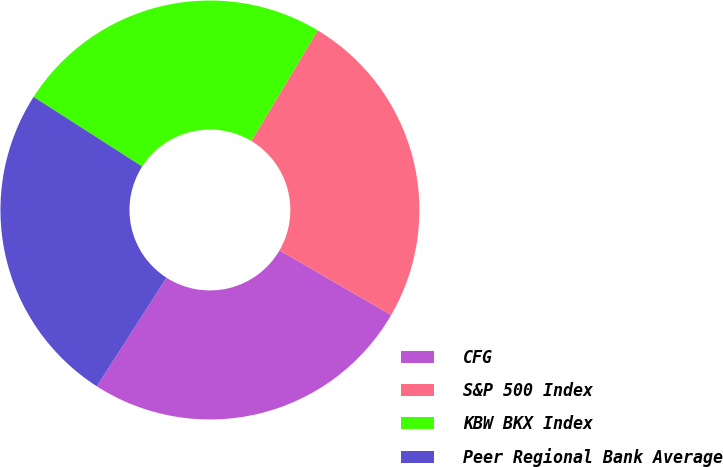Convert chart to OTSL. <chart><loc_0><loc_0><loc_500><loc_500><pie_chart><fcel>CFG<fcel>S&P 500 Index<fcel>KBW BKX Index<fcel>Peer Regional Bank Average<nl><fcel>25.71%<fcel>24.76%<fcel>24.52%<fcel>25.0%<nl></chart> 